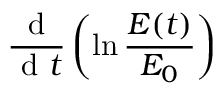<formula> <loc_0><loc_0><loc_500><loc_500>\frac { d } { d t } \left ( \ln \frac { E ( t ) } { E _ { 0 } } \right )</formula> 